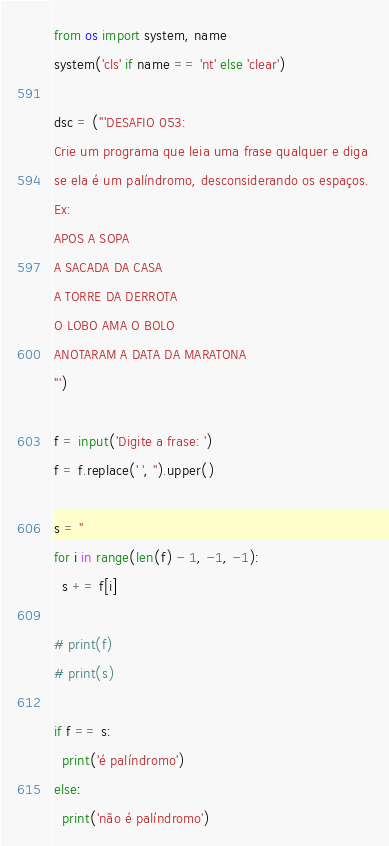Convert code to text. <code><loc_0><loc_0><loc_500><loc_500><_Python_>from os import system, name
system('cls' if name == 'nt' else 'clear')

dsc = ('''DESAFIO 053:
Crie um programa que leia uma frase qualquer e diga 
se ela é um palíndromo, desconsiderando os espaços.
Ex:
APOS A SOPA
A SACADA DA CASA
A TORRE DA DERROTA
O LOBO AMA O BOLO
ANOTARAM A DATA DA MARATONA
''')

f = input('Digite a frase: ')
f = f.replace(' ', '').upper()

s = ''
for i in range(len(f) - 1, -1, -1):
  s += f[i]

# print(f)
# print(s)

if f == s:
  print('é palíndromo')
else:
  print('não é palíndromo')
</code> 